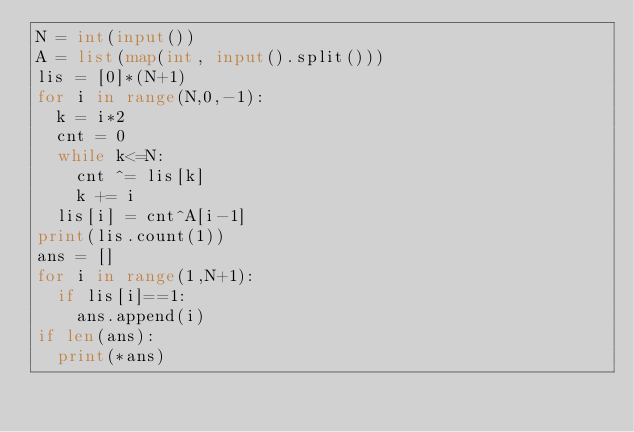Convert code to text. <code><loc_0><loc_0><loc_500><loc_500><_Python_>N = int(input())
A = list(map(int, input().split()))
lis = [0]*(N+1)
for i in range(N,0,-1):
  k = i*2
  cnt = 0
  while k<=N:
    cnt ^= lis[k]
    k += i
  lis[i] = cnt^A[i-1]
print(lis.count(1))
ans = []
for i in range(1,N+1):
  if lis[i]==1:
    ans.append(i)
if len(ans):
  print(*ans)</code> 